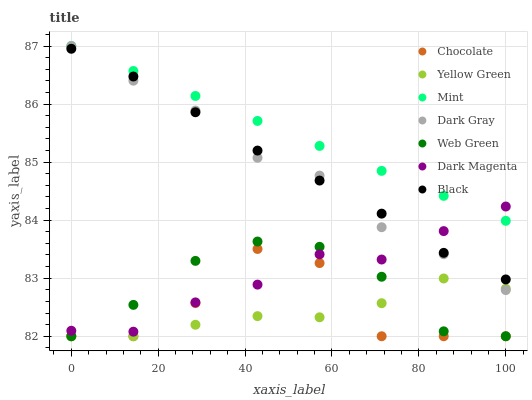Does Yellow Green have the minimum area under the curve?
Answer yes or no. Yes. Does Mint have the maximum area under the curve?
Answer yes or no. Yes. Does Web Green have the minimum area under the curve?
Answer yes or no. No. Does Web Green have the maximum area under the curve?
Answer yes or no. No. Is Mint the smoothest?
Answer yes or no. Yes. Is Chocolate the roughest?
Answer yes or no. Yes. Is Web Green the smoothest?
Answer yes or no. No. Is Web Green the roughest?
Answer yes or no. No. Does Web Green have the lowest value?
Answer yes or no. Yes. Does Dark Gray have the lowest value?
Answer yes or no. No. Does Mint have the highest value?
Answer yes or no. Yes. Does Web Green have the highest value?
Answer yes or no. No. Is Chocolate less than Dark Gray?
Answer yes or no. Yes. Is Dark Magenta greater than Yellow Green?
Answer yes or no. Yes. Does Dark Magenta intersect Chocolate?
Answer yes or no. Yes. Is Dark Magenta less than Chocolate?
Answer yes or no. No. Is Dark Magenta greater than Chocolate?
Answer yes or no. No. Does Chocolate intersect Dark Gray?
Answer yes or no. No. 